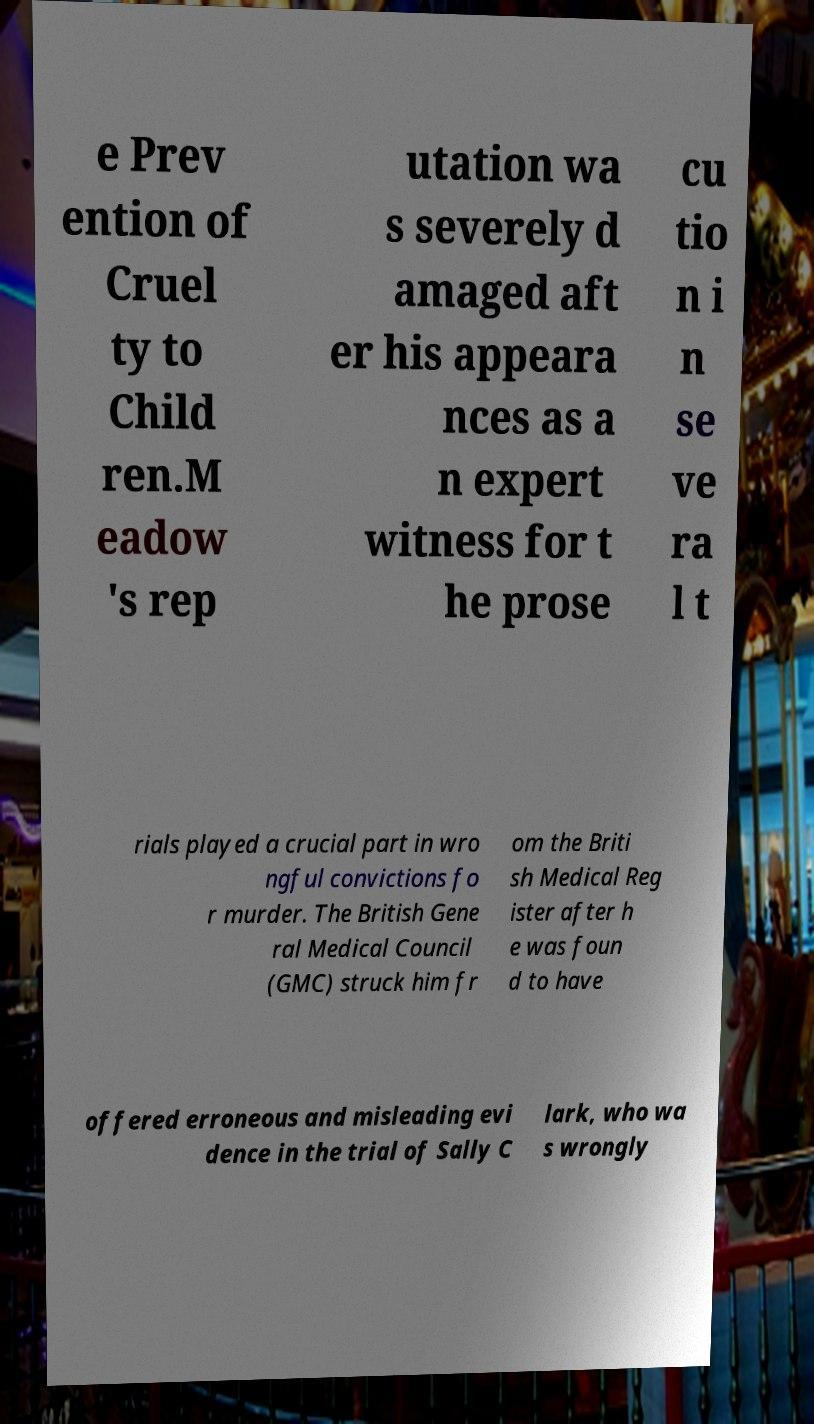There's text embedded in this image that I need extracted. Can you transcribe it verbatim? e Prev ention of Cruel ty to Child ren.M eadow 's rep utation wa s severely d amaged aft er his appeara nces as a n expert witness for t he prose cu tio n i n se ve ra l t rials played a crucial part in wro ngful convictions fo r murder. The British Gene ral Medical Council (GMC) struck him fr om the Briti sh Medical Reg ister after h e was foun d to have offered erroneous and misleading evi dence in the trial of Sally C lark, who wa s wrongly 